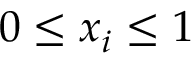<formula> <loc_0><loc_0><loc_500><loc_500>0 \leq x _ { i } \leq 1</formula> 